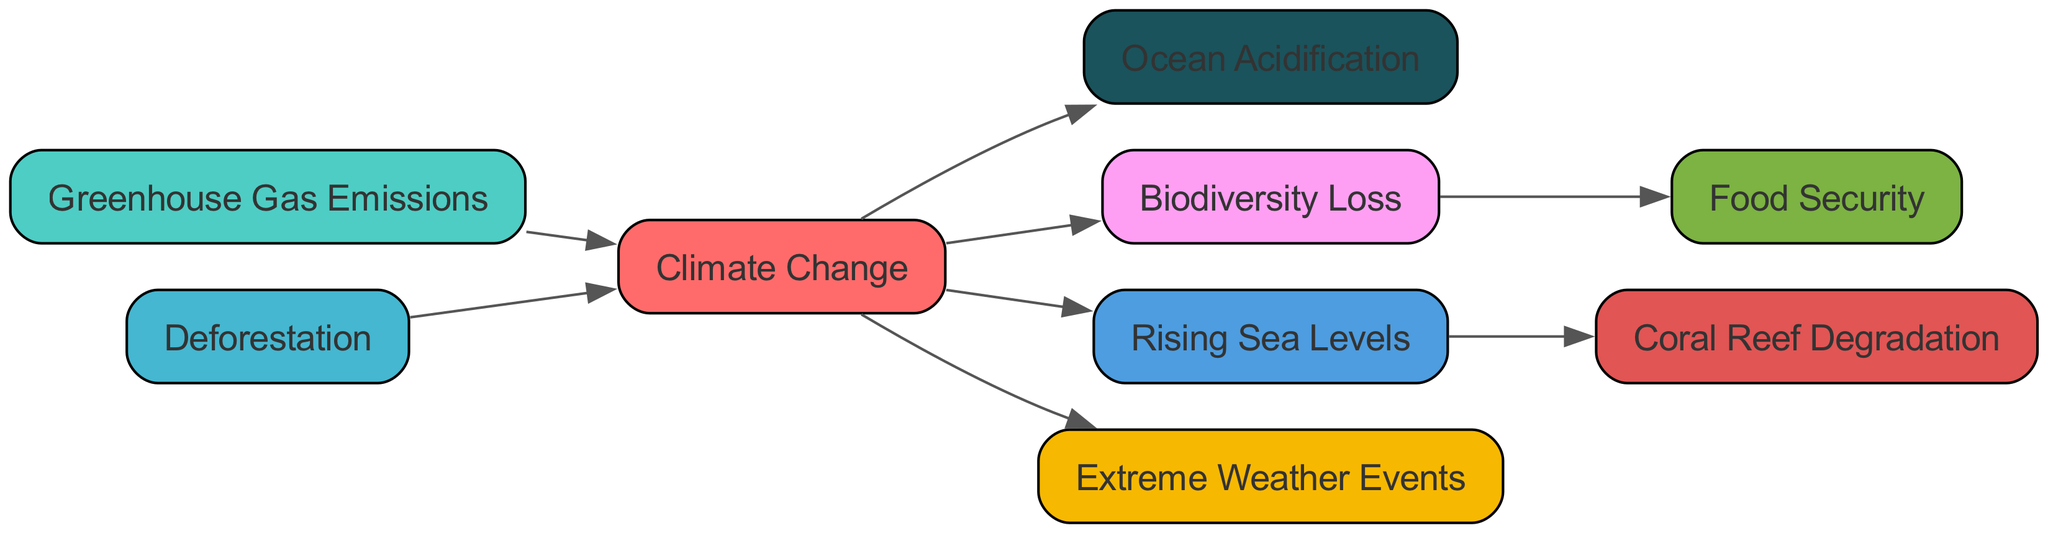How many nodes are present in the diagram? The diagram includes nodes for each factor related to climate change, such as Greenhouse Gas Emissions, Deforestation, etc. By counting all the unique nodes listed, we find there are 9 nodes in total.
Answer: 9 What is the direct cause of Ocean Acidification? According to the directed graph, Ocean Acidification is directly caused by Climate Change, indicated by the directed edge leading from Climate Change to Ocean Acidification.
Answer: Climate Change Which node leads to Food Security? The node leading to Food Security is Biodiversity Loss, as indicated by the directed edge going from Biodiversity Loss to Food Security.
Answer: Biodiversity Loss What is a consequence of Rising Sea Levels? Rising Sea Levels lead to Coral Reef Degradation as shown by the directed edge from Rising Sea Levels to Coral Reef Degradation.
Answer: Coral Reef Degradation How many edges are there in the diagram? Count the edges or connections between nodes in the diagram. The total number of directed edges representing these connections is 8.
Answer: 8 If Greenhouse Gas Emissions are reduced, which node might be positively affected indirectly? Reducing Greenhouse Gas Emissions would lessen Climate Change, which in turn could mitigate Biodiversity Loss as Climate Change negatively affects it. Thus, Biodiversity Loss could be positively affected.
Answer: Biodiversity Loss What are two effects of Climate Change? Climate Change has multiple effects, including Rising Sea Levels and Extreme Weather Events, which can be seen from the directed edges leading from Climate Change to both of these nodes.
Answer: Rising Sea Levels and Extreme Weather Events Which nodes are connected to Deforestation? Deforestation directly leads to Climate Change, so it is connected to that node. Therefore, the only direct connection from Deforestation is to Climate Change.
Answer: Climate Change 